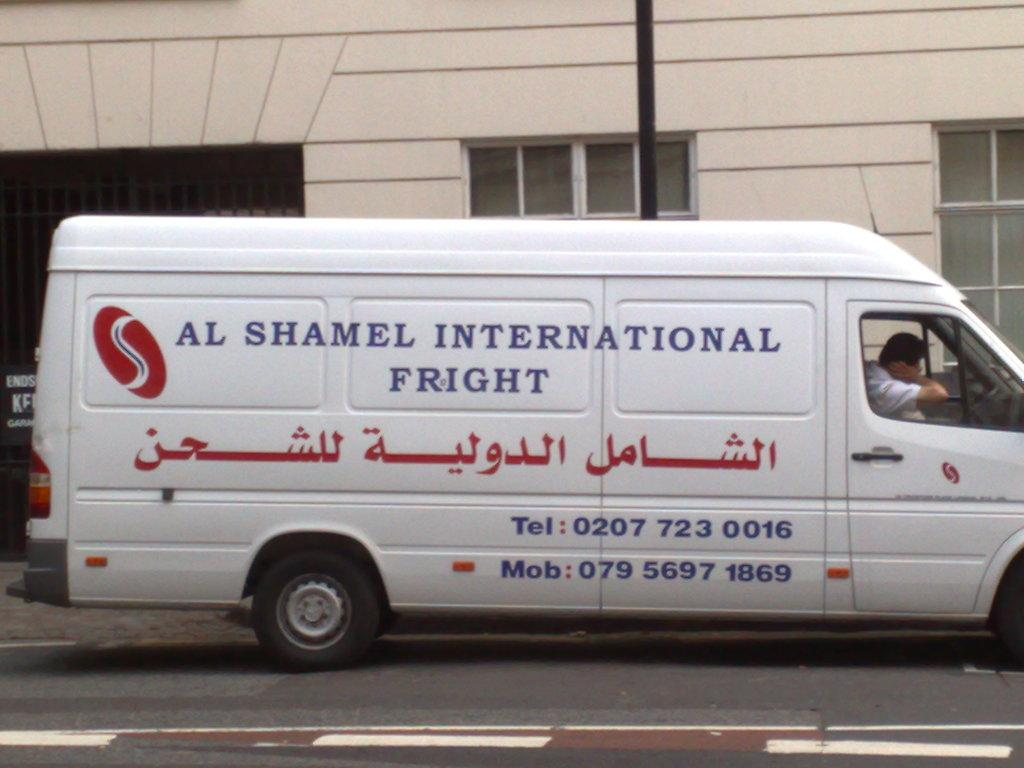<image>
Create a compact narrative representing the image presented. A white van says Al Shamel International Fright in blue letters. 